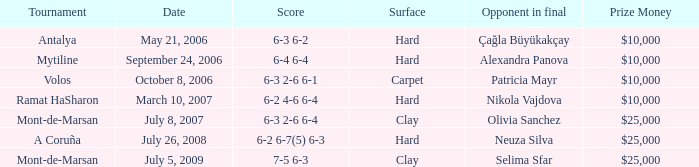What is the date of the match on clay with score of 6-3 2-6 6-4? July 8, 2007. 